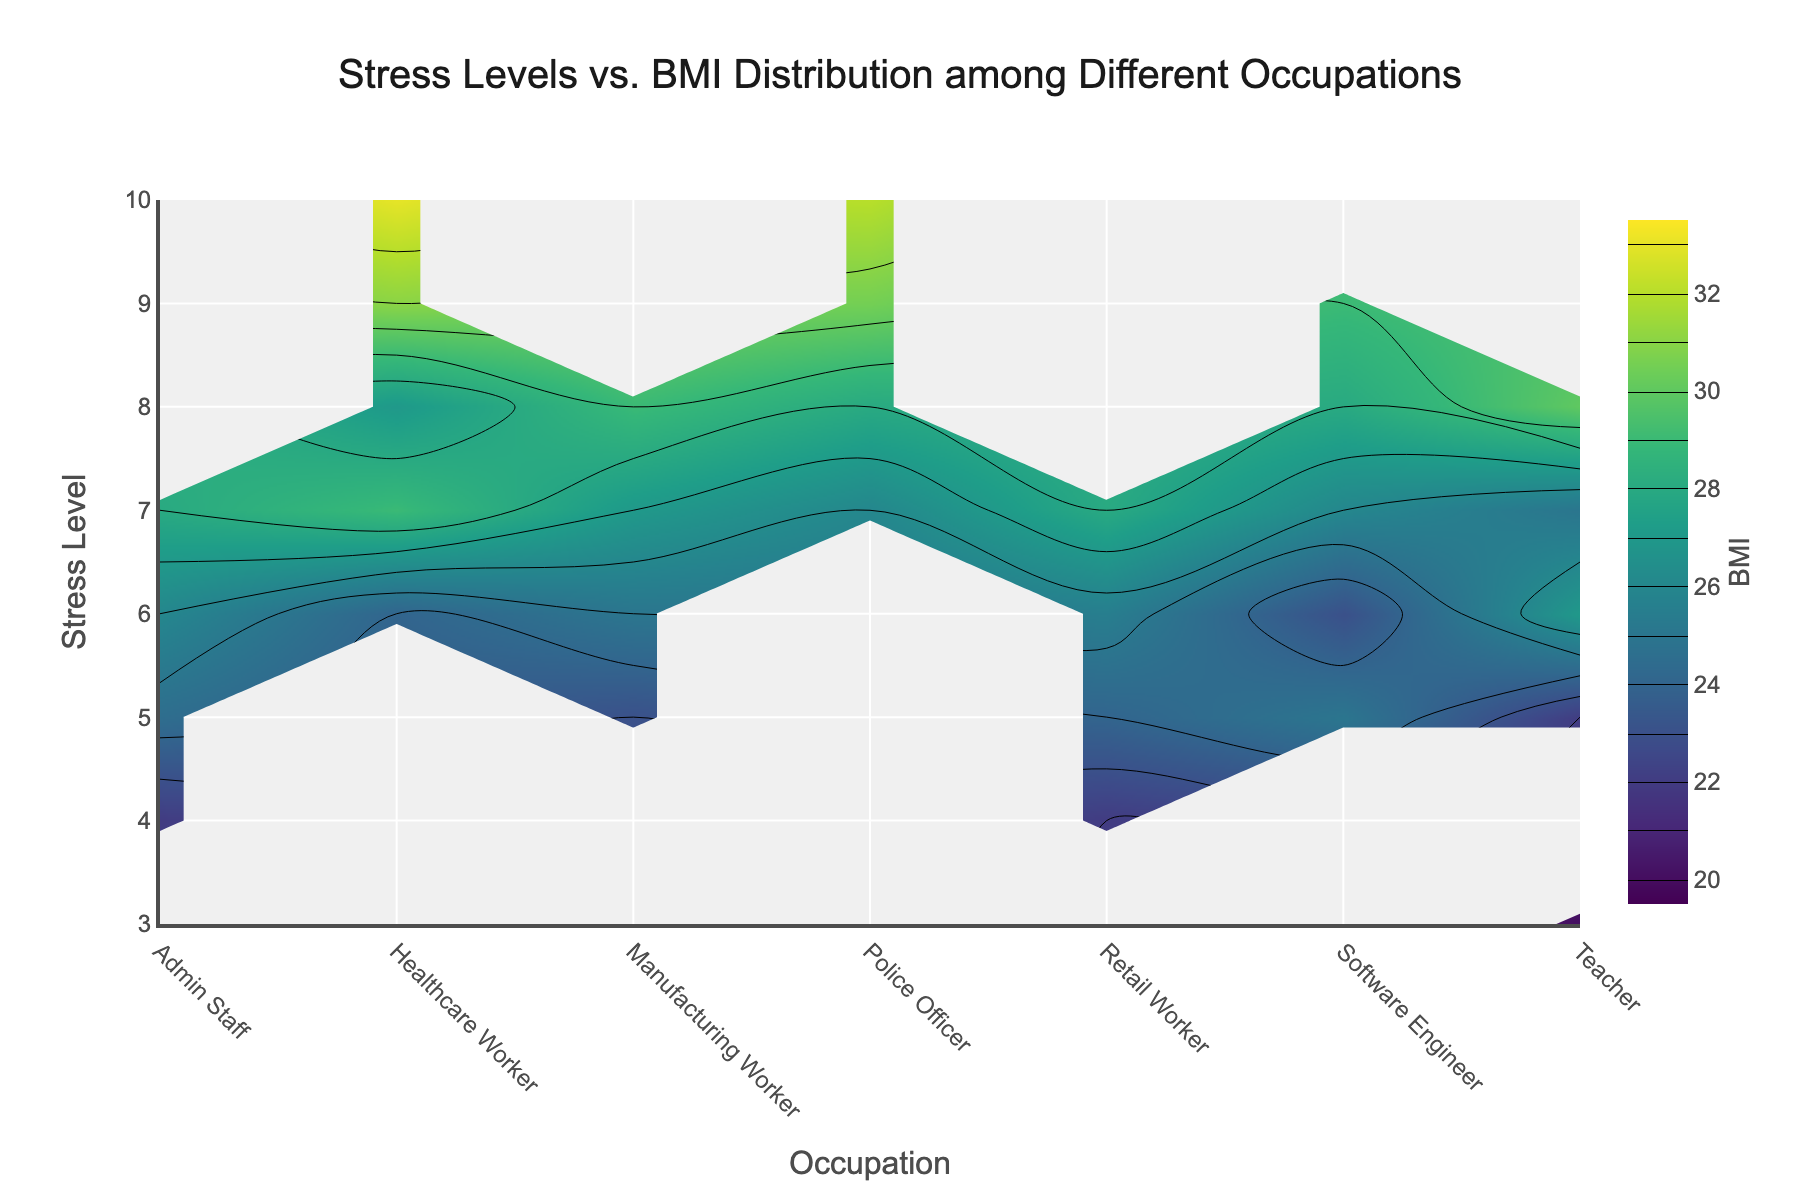What's the title of the figure? The title is usually located at the top center of the plot. The text mentions the distribution of stress levels versus BMI across various occupations.
Answer: Stress Levels vs. BMI Distribution among Different Occupations Which occupation shows the highest average BMI? By examining the contours and color gradient in the figure, the Healthcare Worker appears in the higher BMI ranges more frequently.
Answer: Healthcare Worker What is the range of stress levels displayed on the y-axis? The y-axis contains numerical levels indicating stress. From the visual, they span from 3 to 10.
Answer: 3 to 10 Which occupation tends to have higher stress levels: Retail Worker or Police Officer? Looking at where the highest stress levels appear on the y-axis for these occupations, Police Officer consistently shows higher stress contours.
Answer: Police Officer What's the average BMI for the stress level of 6? To find the average BMI for stress level 6, average the BMI values at that y-axis level across all occupations. Confirm via the contours in that row.
Answer: 25.29 Which occupation shows the widest range of BMI values across different stress levels? The contours spreading across the most different colors indicate the widest BMI variance. Software Engineers show a significant spread from BMI 23 to 29.
Answer: Software Engineer Which occupation tends to have lower BMI for mid-range stress levels (around 6-7)? By examining the contour levels and the color represented between mid-range stress levels, Retail Workers show lower BMI values in this range.
Answer: Retail Worker Is there any occupation that maintains a relatively constant BMI with increasing stress levels? Admin Staff shows relatively consistent BMI levels around 24 to 28 despite varying stress levels, visible from more uniform contour spacing.
Answer: Admin Staff Which occupation show the highest BMI at the highest stress level? By identifying the highest stress level (10) and following its contour, Police Officers have a marked BMI value of 32 or higher at this stress level.
Answer: Police Officer Are there any stress levels where no data is available for certain occupations? By examining contours, gaps appear or are less defined for Healthcare Workers at stress levels below 6.
Answer: Yes 